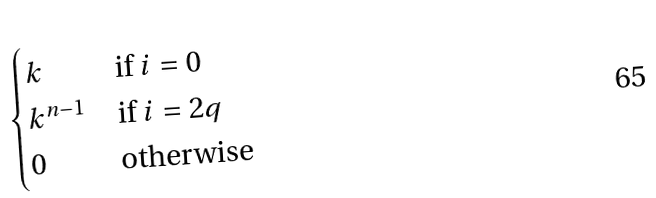<formula> <loc_0><loc_0><loc_500><loc_500>\begin{cases} k & \text {if $i=0$} \\ k ^ { n - 1 } & \text {if $i = 2 q$} \\ 0 & \text {otherwise} \end{cases}</formula> 